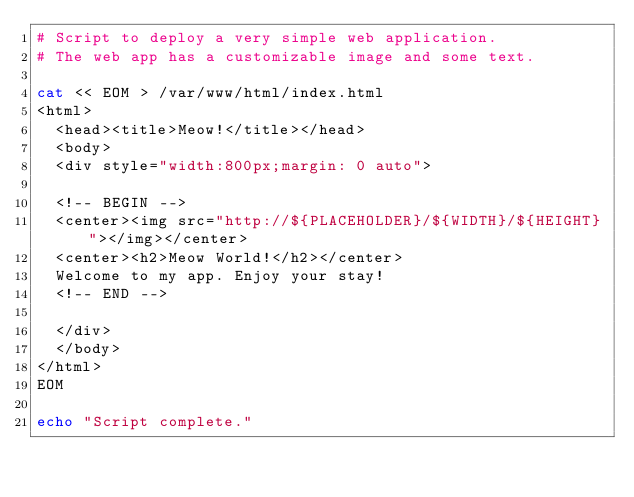<code> <loc_0><loc_0><loc_500><loc_500><_Bash_># Script to deploy a very simple web application.
# The web app has a customizable image and some text.

cat << EOM > /var/www/html/index.html
<html>
  <head><title>Meow!</title></head>
  <body>
  <div style="width:800px;margin: 0 auto">

  <!-- BEGIN -->
  <center><img src="http://${PLACEHOLDER}/${WIDTH}/${HEIGHT}"></img></center>
  <center><h2>Meow World!</h2></center>
  Welcome to my app. Enjoy your stay!
  <!-- END -->

  </div>
  </body>
</html>
EOM

echo "Script complete."
</code> 